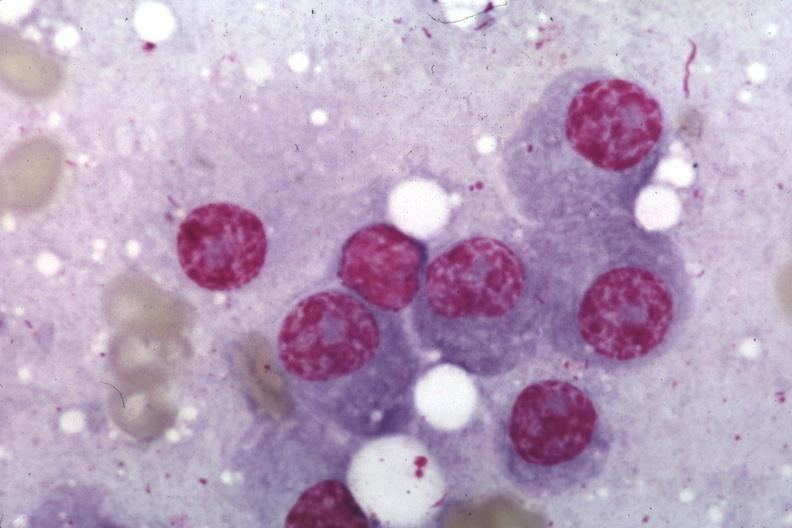what is present?
Answer the question using a single word or phrase. Hematologic 